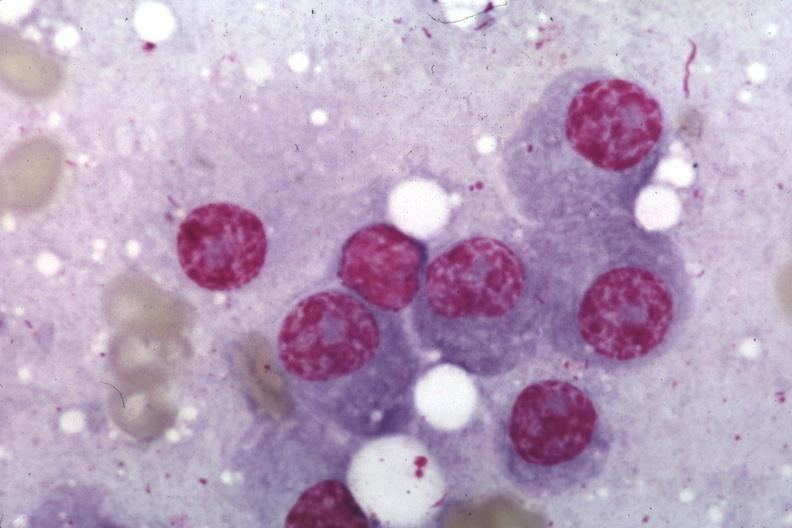what is present?
Answer the question using a single word or phrase. Hematologic 